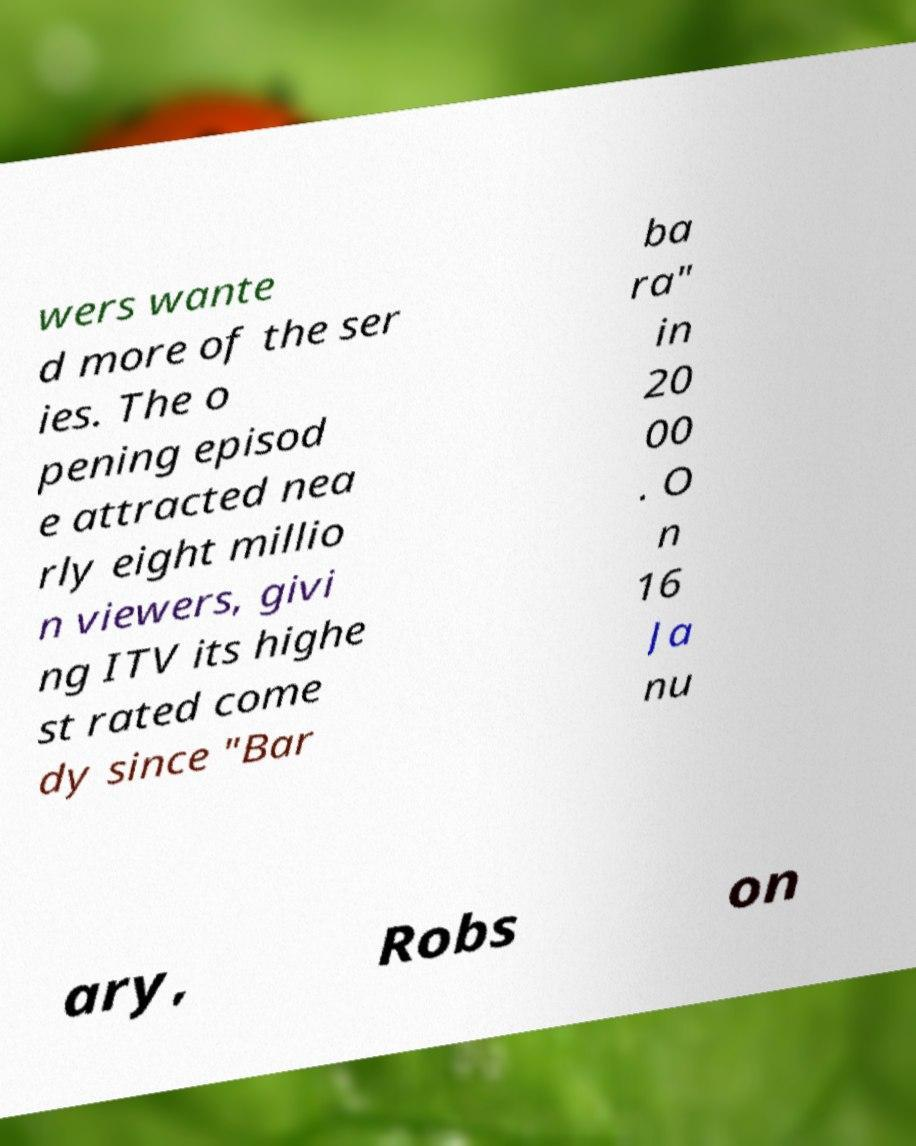There's text embedded in this image that I need extracted. Can you transcribe it verbatim? wers wante d more of the ser ies. The o pening episod e attracted nea rly eight millio n viewers, givi ng ITV its highe st rated come dy since "Bar ba ra" in 20 00 . O n 16 Ja nu ary, Robs on 